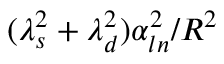Convert formula to latex. <formula><loc_0><loc_0><loc_500><loc_500>( \lambda _ { s } ^ { 2 } + \lambda _ { d } ^ { 2 } ) \alpha _ { \ln } ^ { 2 } / R ^ { 2 }</formula> 